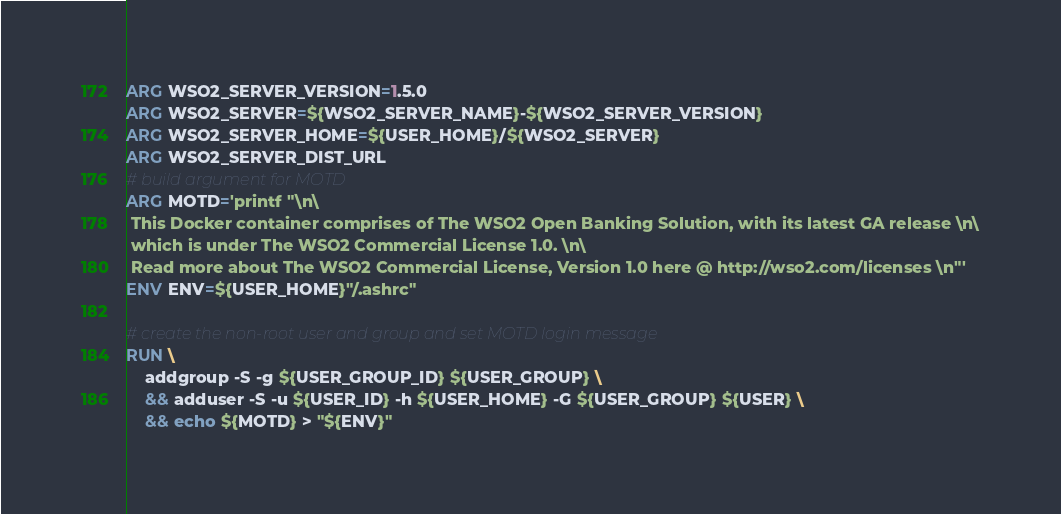<code> <loc_0><loc_0><loc_500><loc_500><_Dockerfile_>ARG WSO2_SERVER_VERSION=1.5.0
ARG WSO2_SERVER=${WSO2_SERVER_NAME}-${WSO2_SERVER_VERSION}
ARG WSO2_SERVER_HOME=${USER_HOME}/${WSO2_SERVER}
ARG WSO2_SERVER_DIST_URL
# build argument for MOTD
ARG MOTD='printf "\n\
 This Docker container comprises of The WSO2 Open Banking Solution, with its latest GA release \n\
 which is under The WSO2 Commercial License 1.0. \n\
 Read more about The WSO2 Commercial License, Version 1.0 here @ http://wso2.com/licenses \n"'
ENV ENV=${USER_HOME}"/.ashrc"

# create the non-root user and group and set MOTD login message
RUN \
    addgroup -S -g ${USER_GROUP_ID} ${USER_GROUP} \
    && adduser -S -u ${USER_ID} -h ${USER_HOME} -G ${USER_GROUP} ${USER} \
    && echo ${MOTD} > "${ENV}"
</code> 